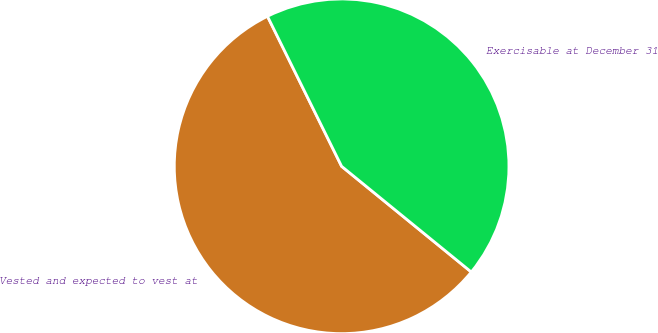Convert chart to OTSL. <chart><loc_0><loc_0><loc_500><loc_500><pie_chart><fcel>Vested and expected to vest at<fcel>Exercisable at December 31<nl><fcel>56.81%<fcel>43.19%<nl></chart> 